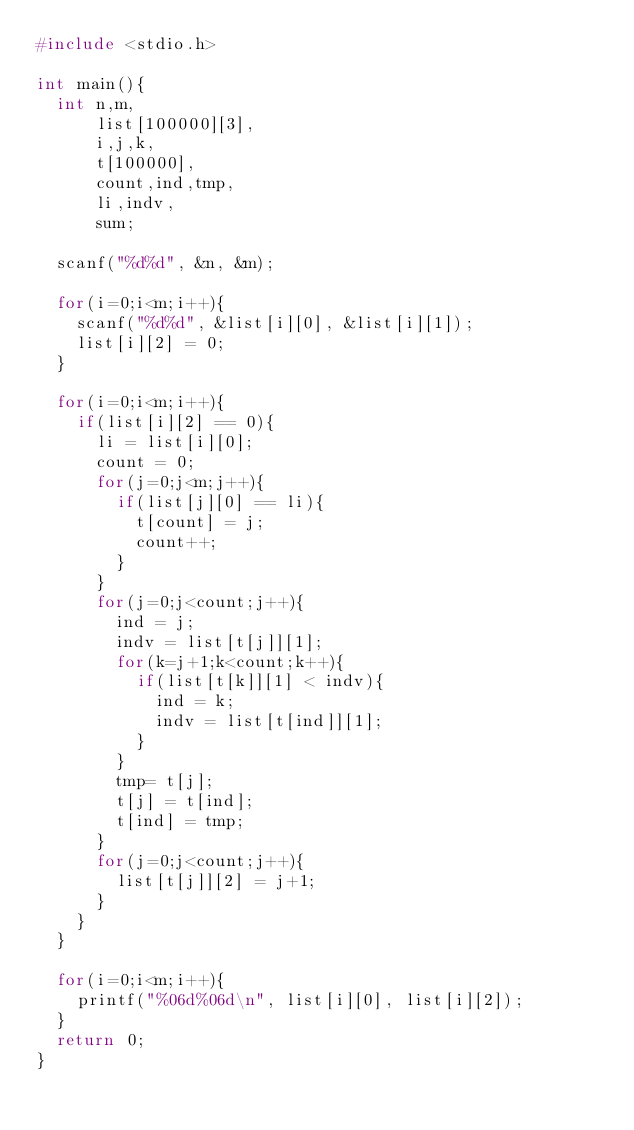<code> <loc_0><loc_0><loc_500><loc_500><_C_>#include <stdio.h>

int main(){
  int n,m,
      list[100000][3],
      i,j,k,
      t[100000],
      count,ind,tmp,
      li,indv,
      sum;
  
  scanf("%d%d", &n, &m);
  
  for(i=0;i<m;i++){
    scanf("%d%d", &list[i][0], &list[i][1]);
    list[i][2] = 0;
  }
  
  for(i=0;i<m;i++){
    if(list[i][2] == 0){
      li = list[i][0];
      count = 0;
      for(j=0;j<m;j++){
        if(list[j][0] == li){
          t[count] = j;
          count++;
        }
      }
      for(j=0;j<count;j++){
        ind = j;
        indv = list[t[j]][1];
        for(k=j+1;k<count;k++){
          if(list[t[k]][1] < indv){
            ind = k;
            indv = list[t[ind]][1];
          }
        }
        tmp= t[j];
        t[j] = t[ind];
        t[ind] = tmp;
      }
      for(j=0;j<count;j++){
        list[t[j]][2] = j+1;
      }
    }
  }
  
  for(i=0;i<m;i++){
    printf("%06d%06d\n", list[i][0], list[i][2]);
  }
  return 0;
}</code> 